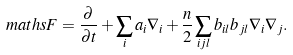<formula> <loc_0><loc_0><loc_500><loc_500>\ m a t h s { F } & = \frac { \partial } { \partial t } + \sum _ { i } a _ { i } \nabla _ { i } + \frac { n } { 2 } \sum _ { i j l } b _ { i l } b _ { j l } \nabla _ { i } \nabla _ { j } .</formula> 